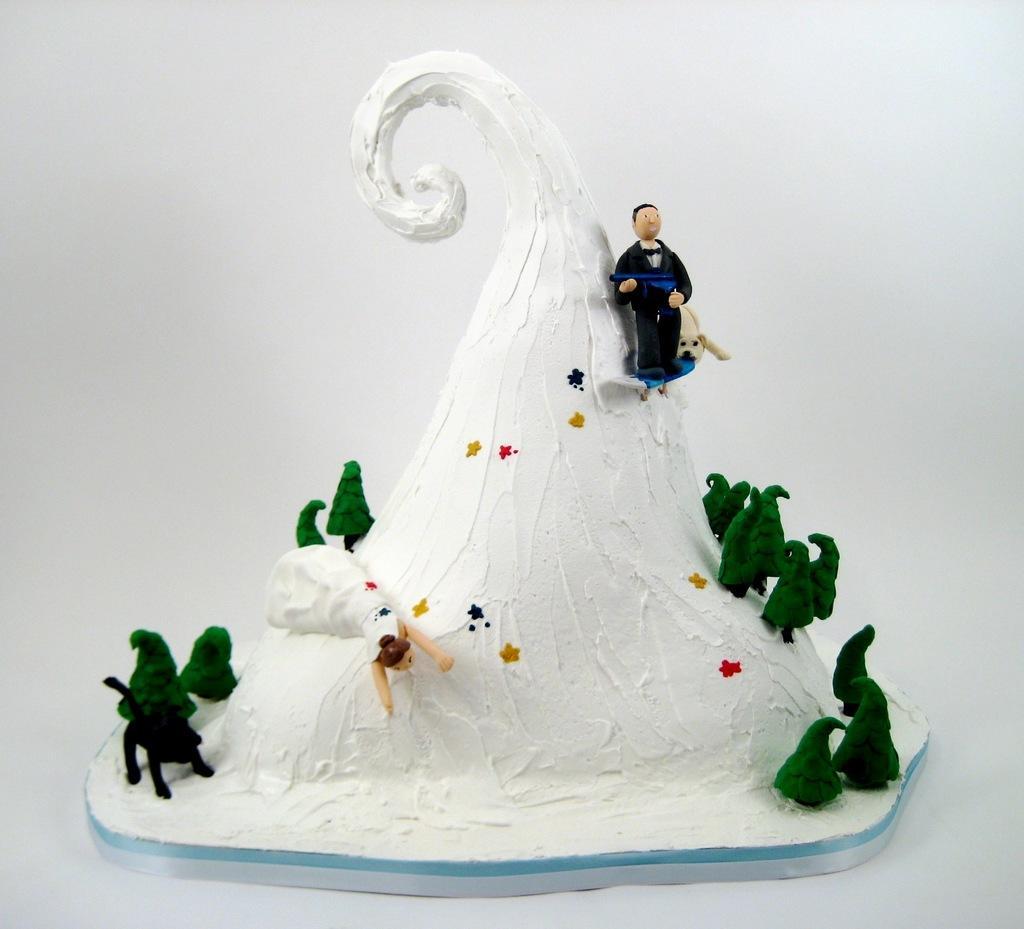Could you give a brief overview of what you see in this image? In this picture we can see a cake. Behind the cake there is the white background. 